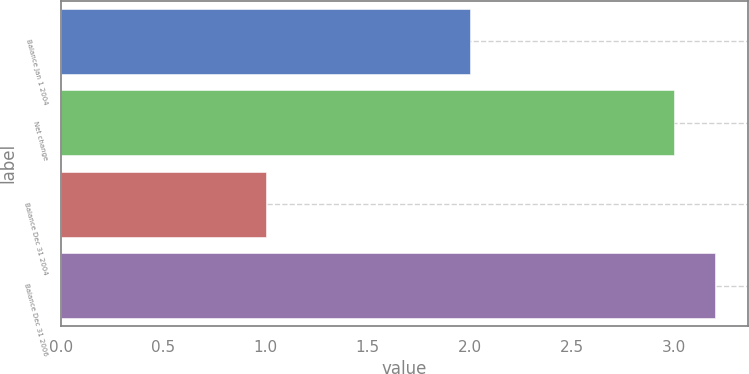Convert chart to OTSL. <chart><loc_0><loc_0><loc_500><loc_500><bar_chart><fcel>Balance Jan 1 2004<fcel>Net change<fcel>Balance Dec 31 2004<fcel>Balance Dec 31 2006<nl><fcel>2<fcel>3<fcel>1<fcel>3.2<nl></chart> 